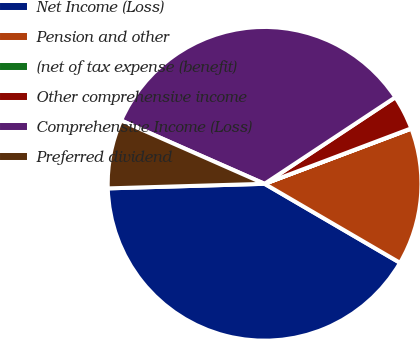Convert chart to OTSL. <chart><loc_0><loc_0><loc_500><loc_500><pie_chart><fcel>Net Income (Loss)<fcel>Pension and other<fcel>(net of tax expense (benefit)<fcel>Other comprehensive income<fcel>Comprehensive Income (Loss)<fcel>Preferred dividend<nl><fcel>41.13%<fcel>14.13%<fcel>0.03%<fcel>3.55%<fcel>34.08%<fcel>7.08%<nl></chart> 